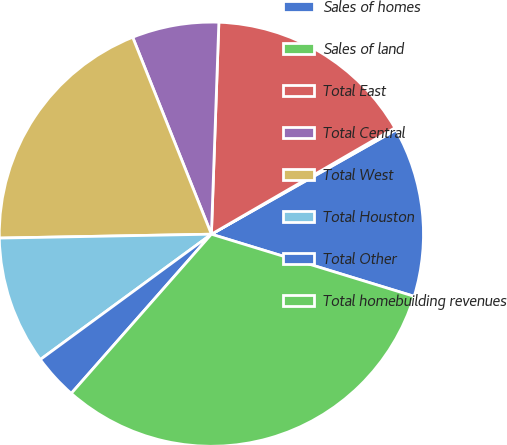Convert chart to OTSL. <chart><loc_0><loc_0><loc_500><loc_500><pie_chart><fcel>Sales of homes<fcel>Sales of land<fcel>Total East<fcel>Total Central<fcel>Total West<fcel>Total Houston<fcel>Total Other<fcel>Total homebuilding revenues<nl><fcel>12.92%<fcel>0.17%<fcel>16.08%<fcel>6.61%<fcel>19.24%<fcel>9.77%<fcel>3.45%<fcel>31.75%<nl></chart> 